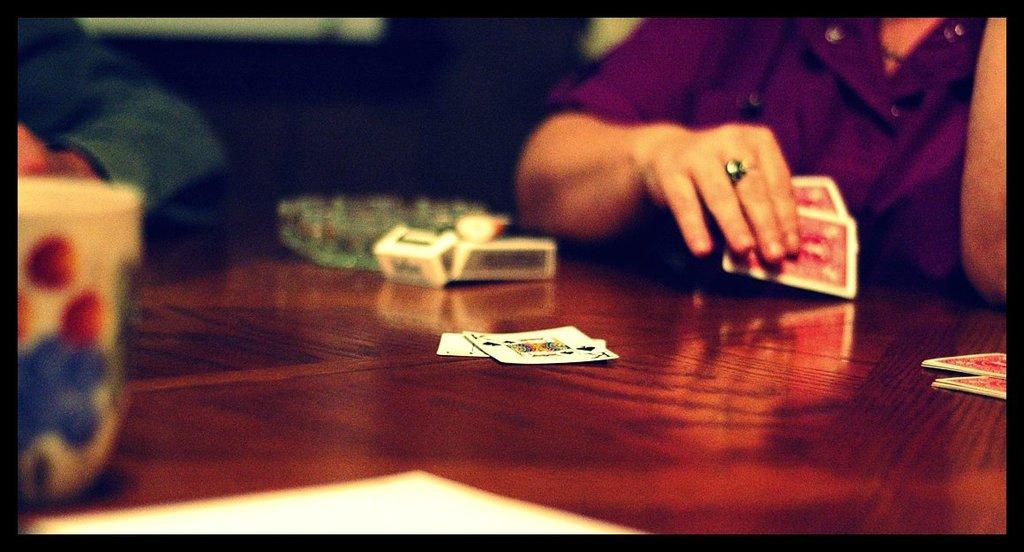Could you give a brief overview of what you see in this image? In the picture we can see playing cards are placed on the table. The background of the image is blurred, where we can see a cup on the left side of the image, we can see a person wearing the purple color shirt is holding a playing cards, we can see a box and ashtray are placed on the table. This part of the image is dark. 